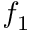Convert formula to latex. <formula><loc_0><loc_0><loc_500><loc_500>f _ { 1 }</formula> 